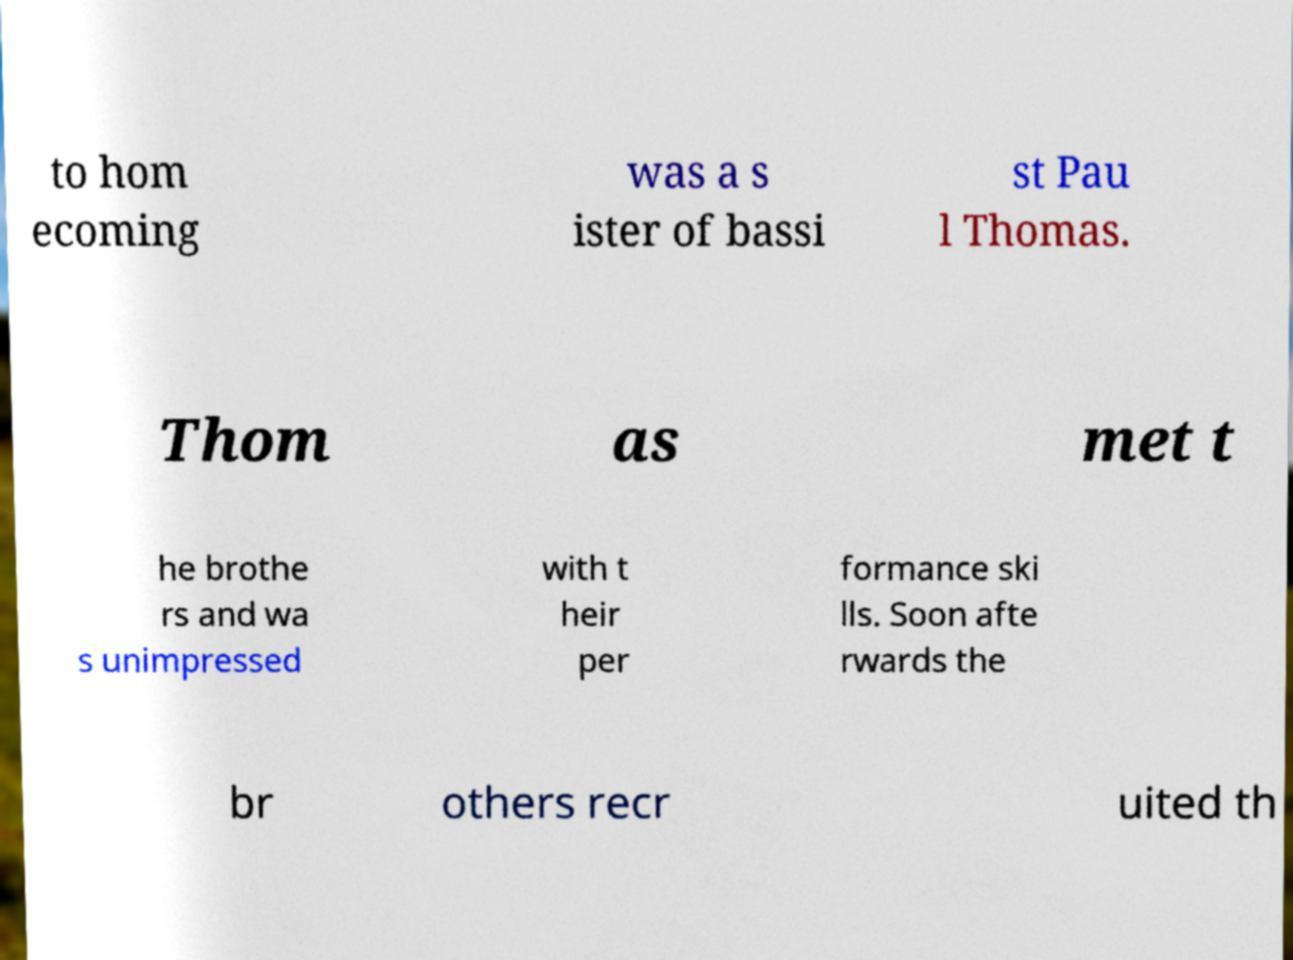Can you accurately transcribe the text from the provided image for me? to hom ecoming was a s ister of bassi st Pau l Thomas. Thom as met t he brothe rs and wa s unimpressed with t heir per formance ski lls. Soon afte rwards the br others recr uited th 